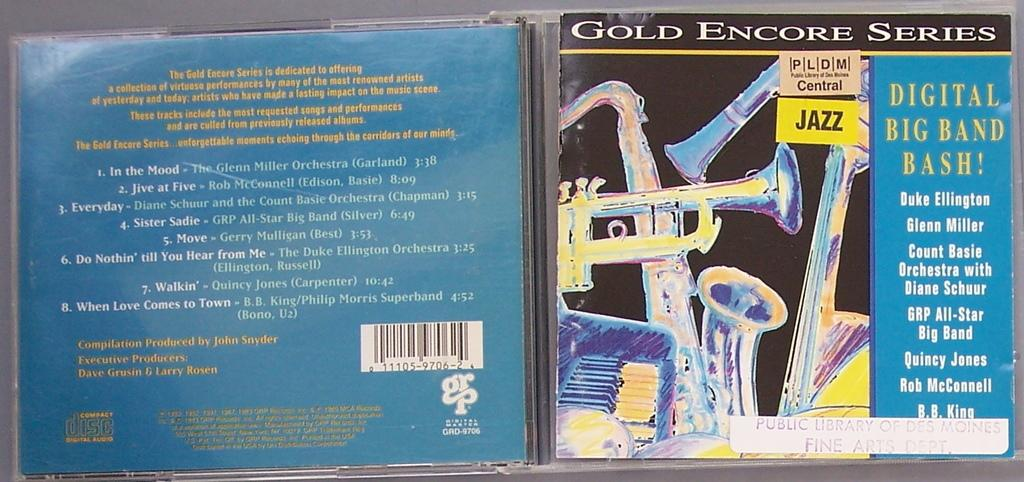<image>
Relay a brief, clear account of the picture shown. a GOLD ENCORE SERIES Jazz music CD which has DIGITAL BIG BAND BASH! on it with the likes of Duke Ellington, Glen Miller, Count Basie, B.B. King, etc. 